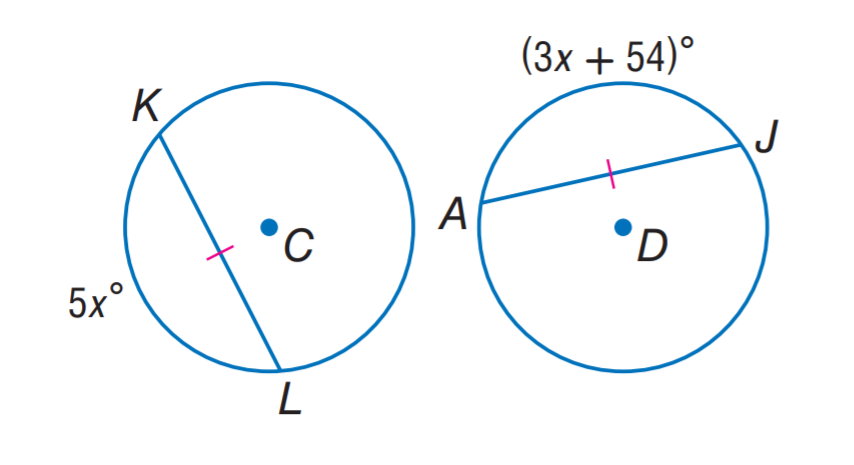Answer the mathemtical geometry problem and directly provide the correct option letter.
Question: \odot C \cong \odot D. Find x.
Choices: A: 13.5 B: 27 C: 54 D: 108 B 